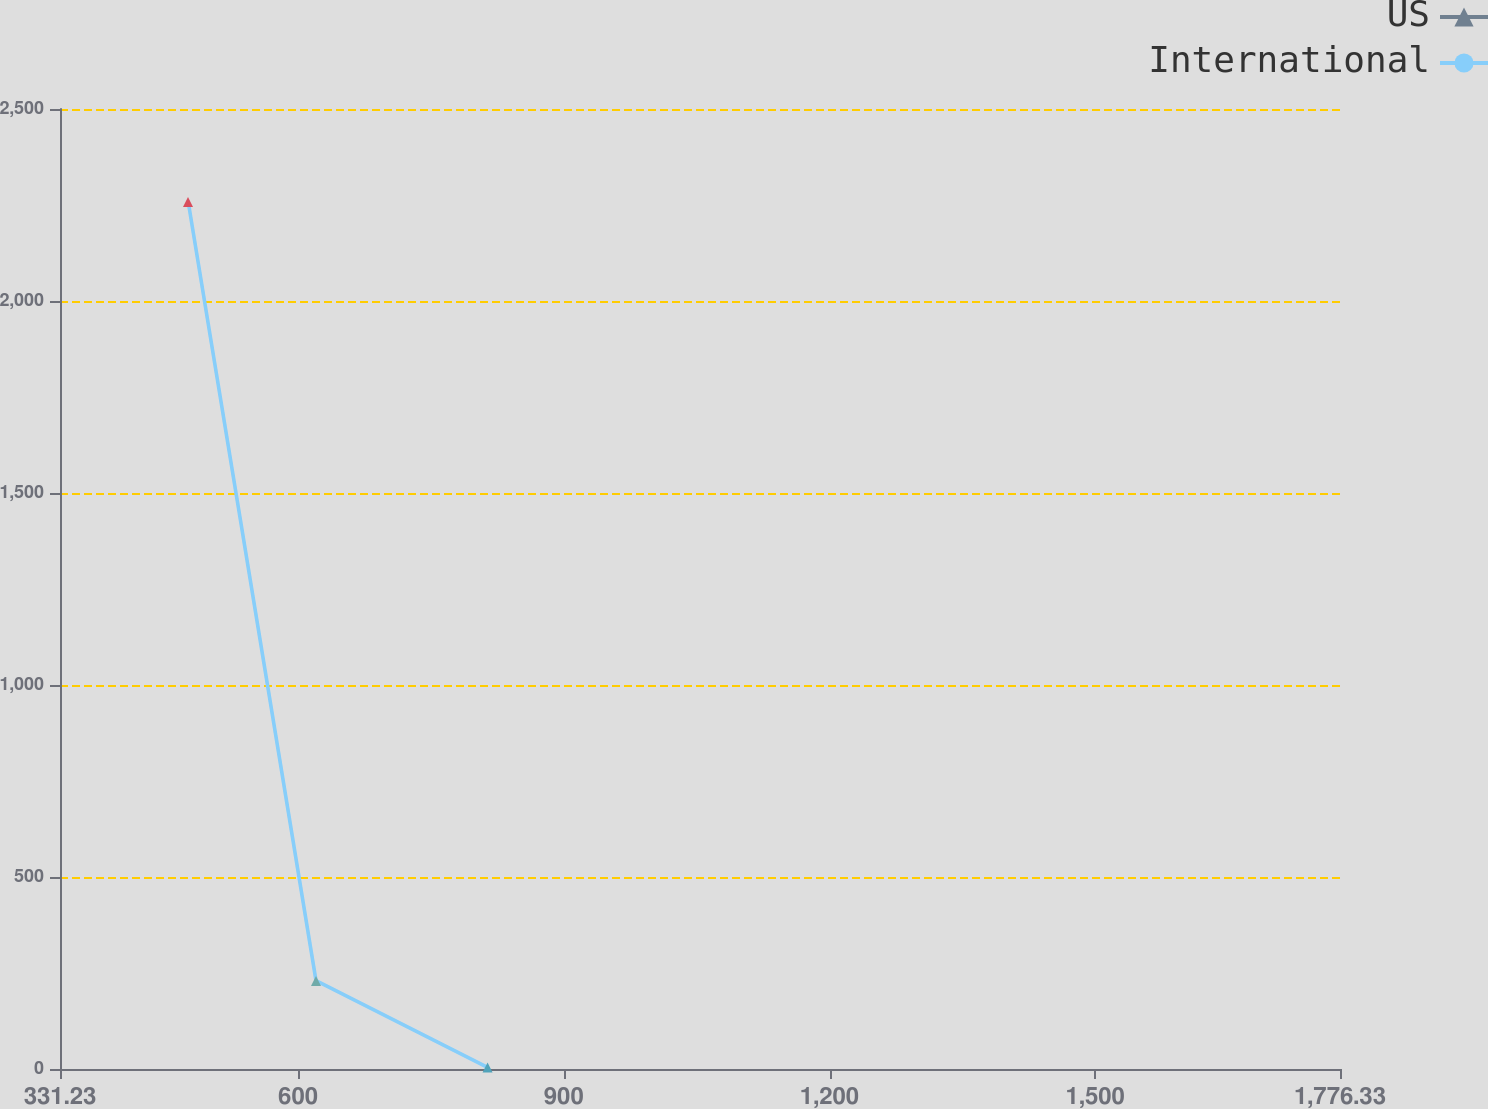Convert chart to OTSL. <chart><loc_0><loc_0><loc_500><loc_500><line_chart><ecel><fcel>US<fcel>International<nl><fcel>475.74<fcel>2257.92<fcel>2261.56<nl><fcel>620.25<fcel>229.49<fcel>230.15<nl><fcel>813.95<fcel>4.11<fcel>4.44<nl><fcel>1920.84<fcel>454.87<fcel>455.86<nl></chart> 